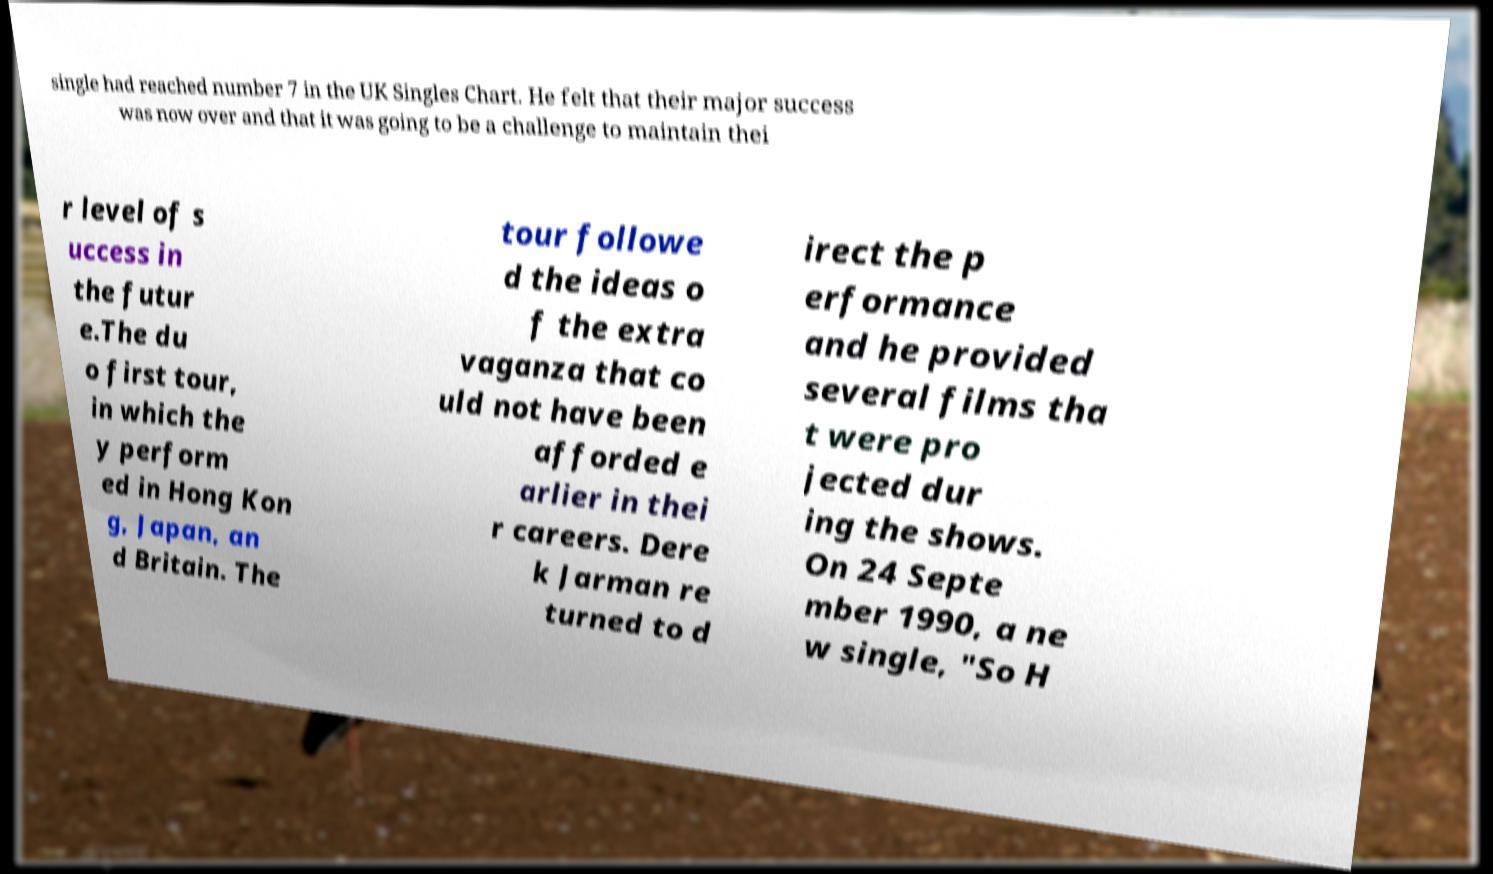There's text embedded in this image that I need extracted. Can you transcribe it verbatim? single had reached number 7 in the UK Singles Chart. He felt that their major success was now over and that it was going to be a challenge to maintain thei r level of s uccess in the futur e.The du o first tour, in which the y perform ed in Hong Kon g, Japan, an d Britain. The tour followe d the ideas o f the extra vaganza that co uld not have been afforded e arlier in thei r careers. Dere k Jarman re turned to d irect the p erformance and he provided several films tha t were pro jected dur ing the shows. On 24 Septe mber 1990, a ne w single, "So H 